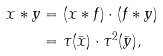<formula> <loc_0><loc_0><loc_500><loc_500>x * y & = ( x * f ) \cdot ( f * y ) \\ & = \tau ( \bar { x } ) \cdot \tau ^ { 2 } ( \bar { y } ) ,</formula> 